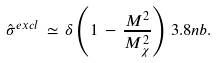Convert formula to latex. <formula><loc_0><loc_0><loc_500><loc_500>\hat { \sigma } ^ { e x c l } \, \simeq \, \delta \left ( 1 \, - \, \frac { M ^ { 2 } } { M _ { \chi } ^ { 2 } } \right ) \, 3 . 8 n b .</formula> 